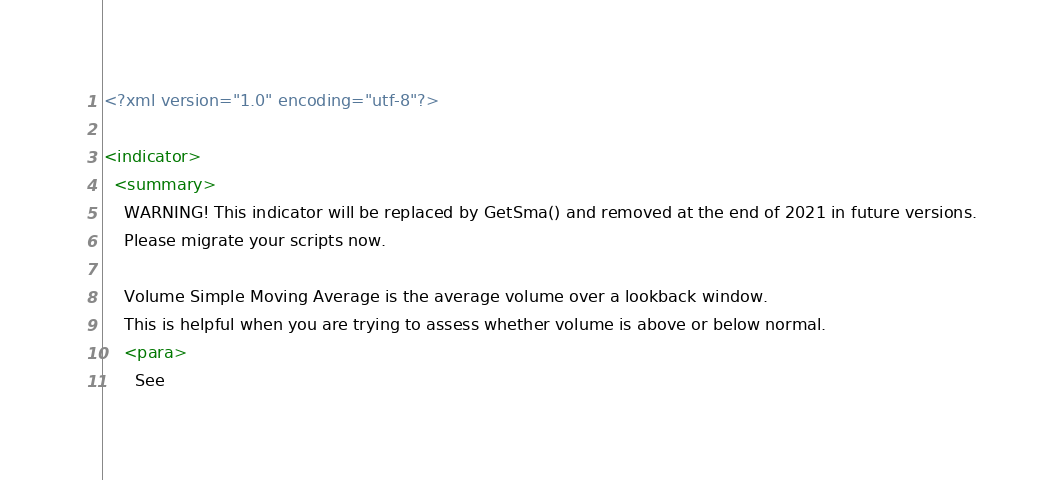<code> <loc_0><loc_0><loc_500><loc_500><_XML_><?xml version="1.0" encoding="utf-8"?>

<indicator>
  <summary>
    WARNING! This indicator will be replaced by GetSma() and removed at the end of 2021 in future versions.
    Please migrate your scripts now.

    Volume Simple Moving Average is the average volume over a lookback window.
    This is helpful when you are trying to assess whether volume is above or below normal.
    <para>
      See</code> 